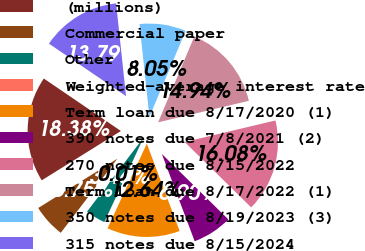<chart> <loc_0><loc_0><loc_500><loc_500><pie_chart><fcel>(millions)<fcel>Commercial paper<fcel>Other<fcel>Weighted-average interest rate<fcel>Term loan due 8/17/2020 (1)<fcel>390 notes due 7/8/2021 (2)<fcel>270 notes due 8/15/2022<fcel>Term loan due 8/17/2022 (1)<fcel>350 notes due 8/19/2023 (3)<fcel>315 notes due 8/15/2024<nl><fcel>18.38%<fcel>5.75%<fcel>3.46%<fcel>0.01%<fcel>12.64%<fcel>6.9%<fcel>16.08%<fcel>14.94%<fcel>8.05%<fcel>13.79%<nl></chart> 